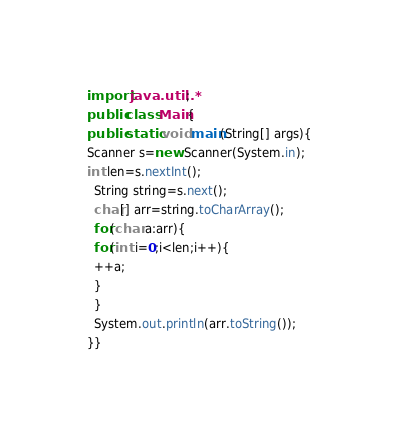<code> <loc_0><loc_0><loc_500><loc_500><_Java_>import java.util.*;
public class Main{
public static void main(String[] args){
Scanner s=new Scanner(System.in);
int len=s.nextInt();
  String string=s.next();
  char[] arr=string.toCharArray();
  for(char a:arr){
  for(int i=0;i<len;i++){
  ++a;
  }
  }
  System.out.println(arr.toString());
}}</code> 